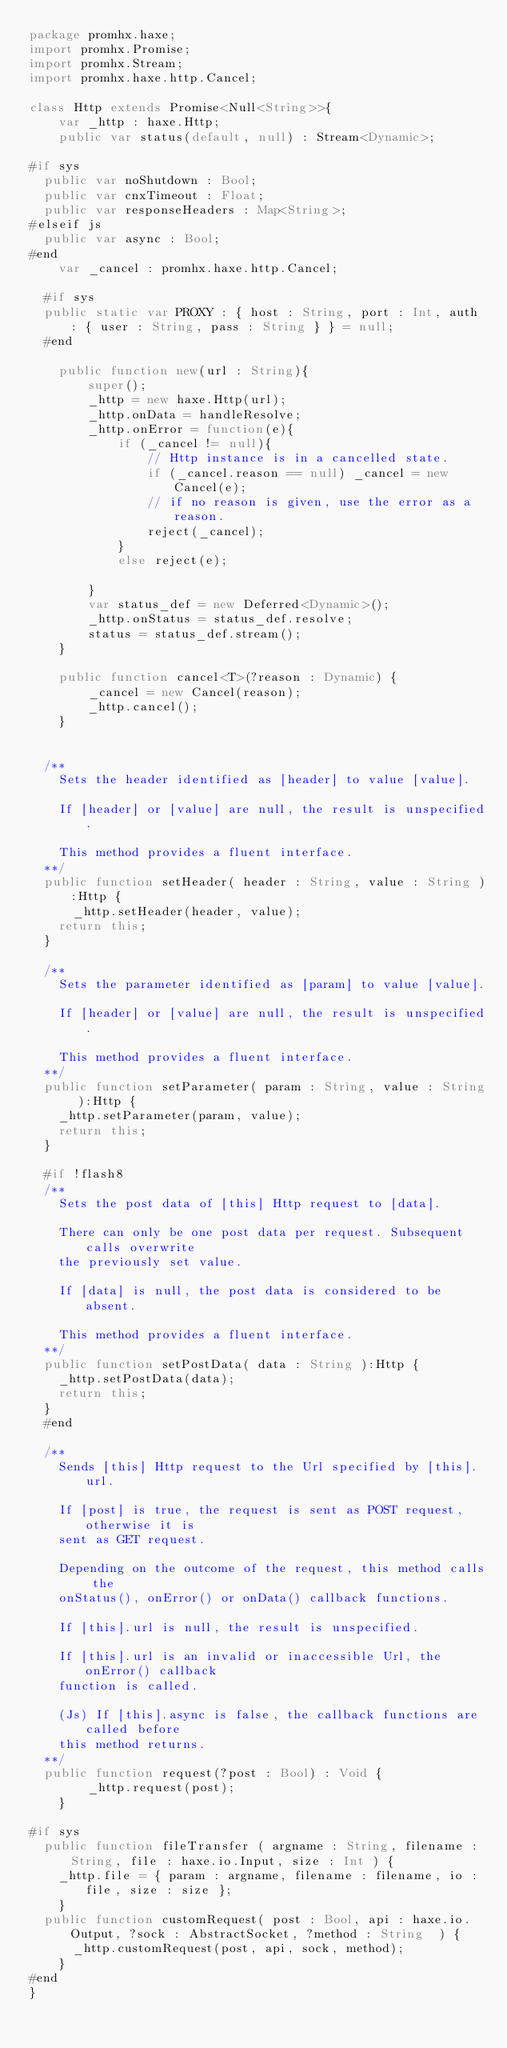<code> <loc_0><loc_0><loc_500><loc_500><_Haxe_>package promhx.haxe;
import promhx.Promise;
import promhx.Stream;
import promhx.haxe.http.Cancel;

class Http extends Promise<Null<String>>{
    var _http : haxe.Http;
    public var status(default, null) : Stream<Dynamic>;

#if sys
	public var noShutdown : Bool;
	public var cnxTimeout : Float;
	public var responseHeaders : Map<String>;
#elseif js
	public var async : Bool;
#end
    var _cancel : promhx.haxe.http.Cancel;

	#if sys
	public static var PROXY : { host : String, port : Int, auth : { user : String, pass : String } } = null;
	#end

    public function new(url : String){
        super();
        _http = new haxe.Http(url);
        _http.onData = handleResolve;
        _http.onError = function(e){
            if (_cancel != null){
                // Http instance is in a cancelled state.
                if (_cancel.reason == null) _cancel = new Cancel(e); 
                // if no reason is given, use the error as a reason.
                reject(_cancel);
            }
            else reject(e);

        }
        var status_def = new Deferred<Dynamic>();
        _http.onStatus = status_def.resolve;
        status = status_def.stream();
    }

    public function cancel<T>(?reason : Dynamic) {
        _cancel = new Cancel(reason);
        _http.cancel();
    }


	/**
		Sets the header identified as [header] to value [value].

		If [header] or [value] are null, the result is unspecified.

		This method provides a fluent interface.
	**/
	public function setHeader( header : String, value : String ):Http {
	    _http.setHeader(header, value);
		return this;
	}

	/**
		Sets the parameter identified as [param] to value [value].

		If [header] or [value] are null, the result is unspecified.

		This method provides a fluent interface.
	**/
	public function setParameter( param : String, value : String ):Http {
		_http.setParameter(param, value);
		return this;
	}

	#if !flash8
	/**
		Sets the post data of [this] Http request to [data].

		There can only be one post data per request. Subsequent calls overwrite
		the previously set value.

		If [data] is null, the post data is considered to be absent.

		This method provides a fluent interface.
	**/
	public function setPostData( data : String ):Http {
		_http.setPostData(data);
		return this;
	}
	#end

	/**
		Sends [this] Http request to the Url specified by [this].url.

		If [post] is true, the request is sent as POST request, otherwise it is
		sent as GET request.

		Depending on the outcome of the request, this method calls the
		onStatus(), onError() or onData() callback functions.

		If [this].url is null, the result is unspecified.

		If [this].url is an invalid or inaccessible Url, the onError() callback
		function is called.

		(Js) If [this].async is false, the callback functions are called before
		this method returns.
	**/
	public function request(?post : Bool) : Void {
        _http.request(post);
    }

#if sys
	public function fileTransfer ( argname : String, filename : String, file : haxe.io.Input, size : Int ) {
		_http.file = { param : argname, filename : filename, io : file, size : size };
    }
	public function customRequest( post : Bool, api : haxe.io.Output, ?sock : AbstractSocket, ?method : String  ) {
	    _http.customRequest(post, api, sock, method);
    }
#end
}

</code> 